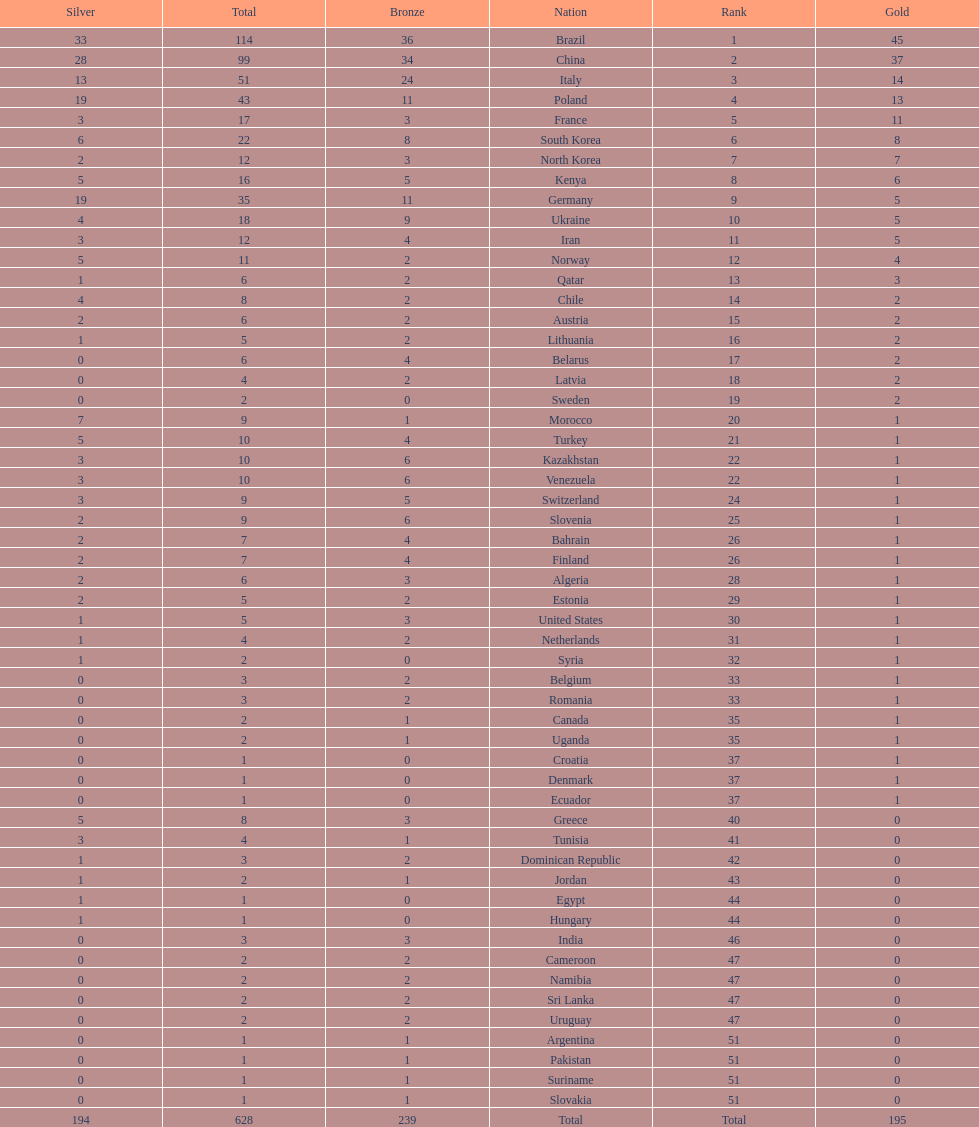Which nation earned the most gold medals? Brazil. 